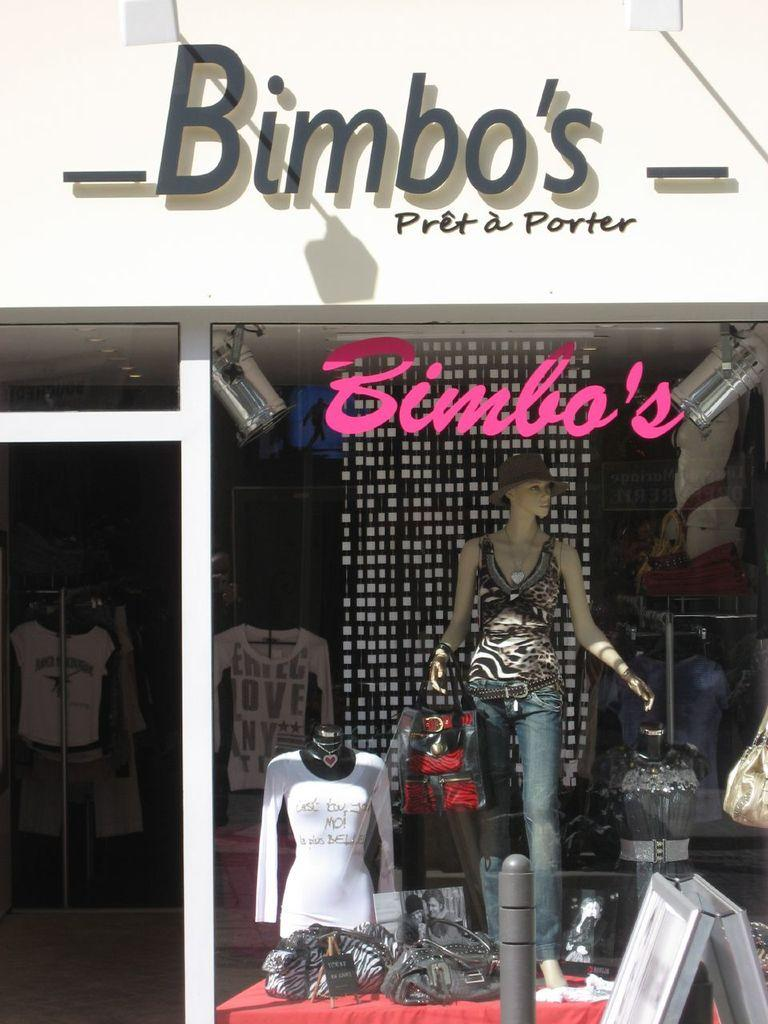<image>
Offer a succinct explanation of the picture presented. a boutique store called bimbos pret a porter 